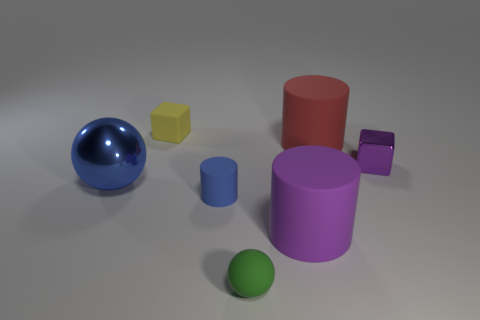Add 1 balls. How many objects exist? 8 Subtract all cylinders. How many objects are left? 4 Subtract all tiny rubber blocks. Subtract all big blue things. How many objects are left? 5 Add 3 big rubber objects. How many big rubber objects are left? 5 Add 4 tiny yellow blocks. How many tiny yellow blocks exist? 5 Subtract 0 gray cubes. How many objects are left? 7 